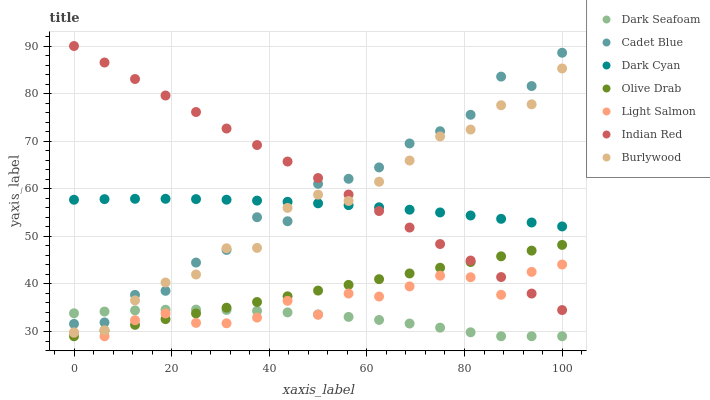Does Dark Seafoam have the minimum area under the curve?
Answer yes or no. Yes. Does Indian Red have the maximum area under the curve?
Answer yes or no. Yes. Does Cadet Blue have the minimum area under the curve?
Answer yes or no. No. Does Cadet Blue have the maximum area under the curve?
Answer yes or no. No. Is Olive Drab the smoothest?
Answer yes or no. Yes. Is Cadet Blue the roughest?
Answer yes or no. Yes. Is Burlywood the smoothest?
Answer yes or no. No. Is Burlywood the roughest?
Answer yes or no. No. Does Light Salmon have the lowest value?
Answer yes or no. Yes. Does Cadet Blue have the lowest value?
Answer yes or no. No. Does Indian Red have the highest value?
Answer yes or no. Yes. Does Cadet Blue have the highest value?
Answer yes or no. No. Is Light Salmon less than Burlywood?
Answer yes or no. Yes. Is Dark Cyan greater than Light Salmon?
Answer yes or no. Yes. Does Light Salmon intersect Indian Red?
Answer yes or no. Yes. Is Light Salmon less than Indian Red?
Answer yes or no. No. Is Light Salmon greater than Indian Red?
Answer yes or no. No. Does Light Salmon intersect Burlywood?
Answer yes or no. No. 